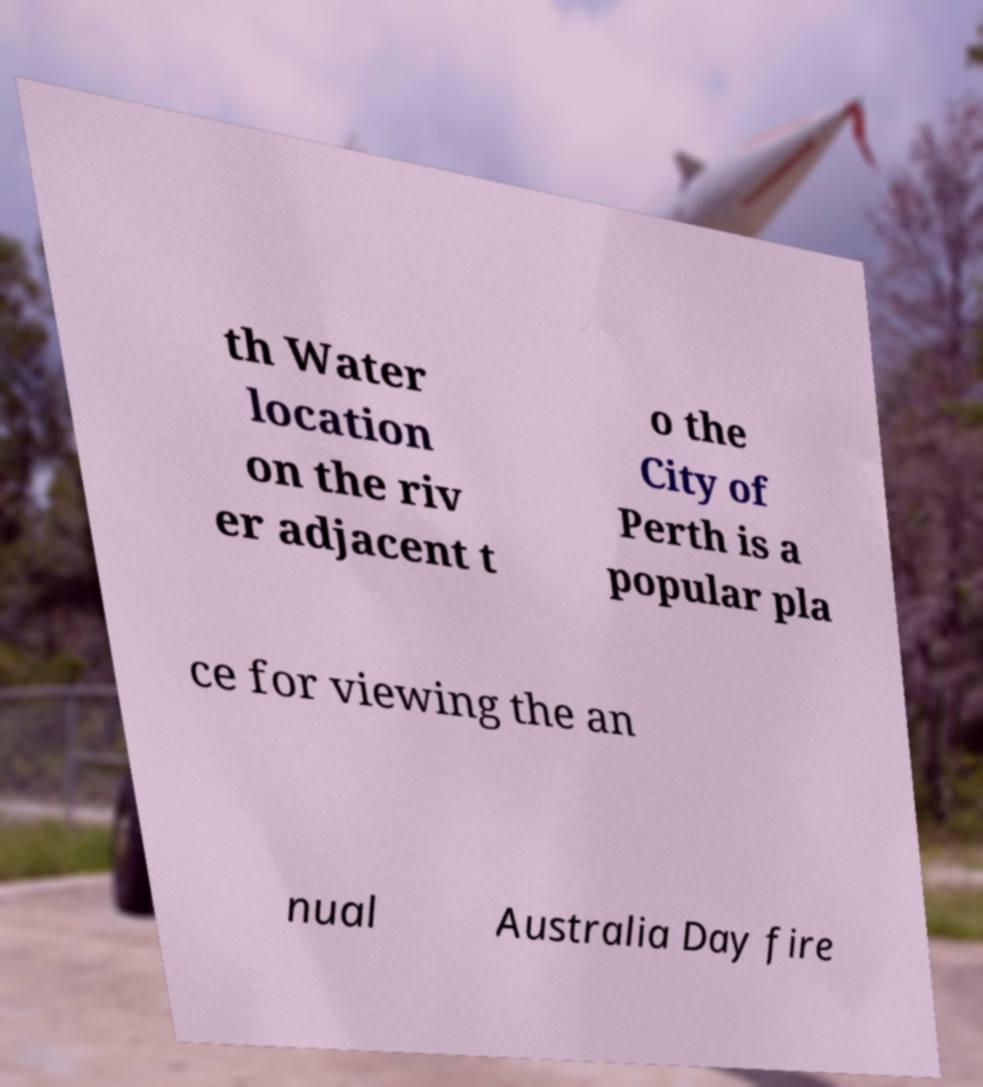Can you accurately transcribe the text from the provided image for me? th Water location on the riv er adjacent t o the City of Perth is a popular pla ce for viewing the an nual Australia Day fire 